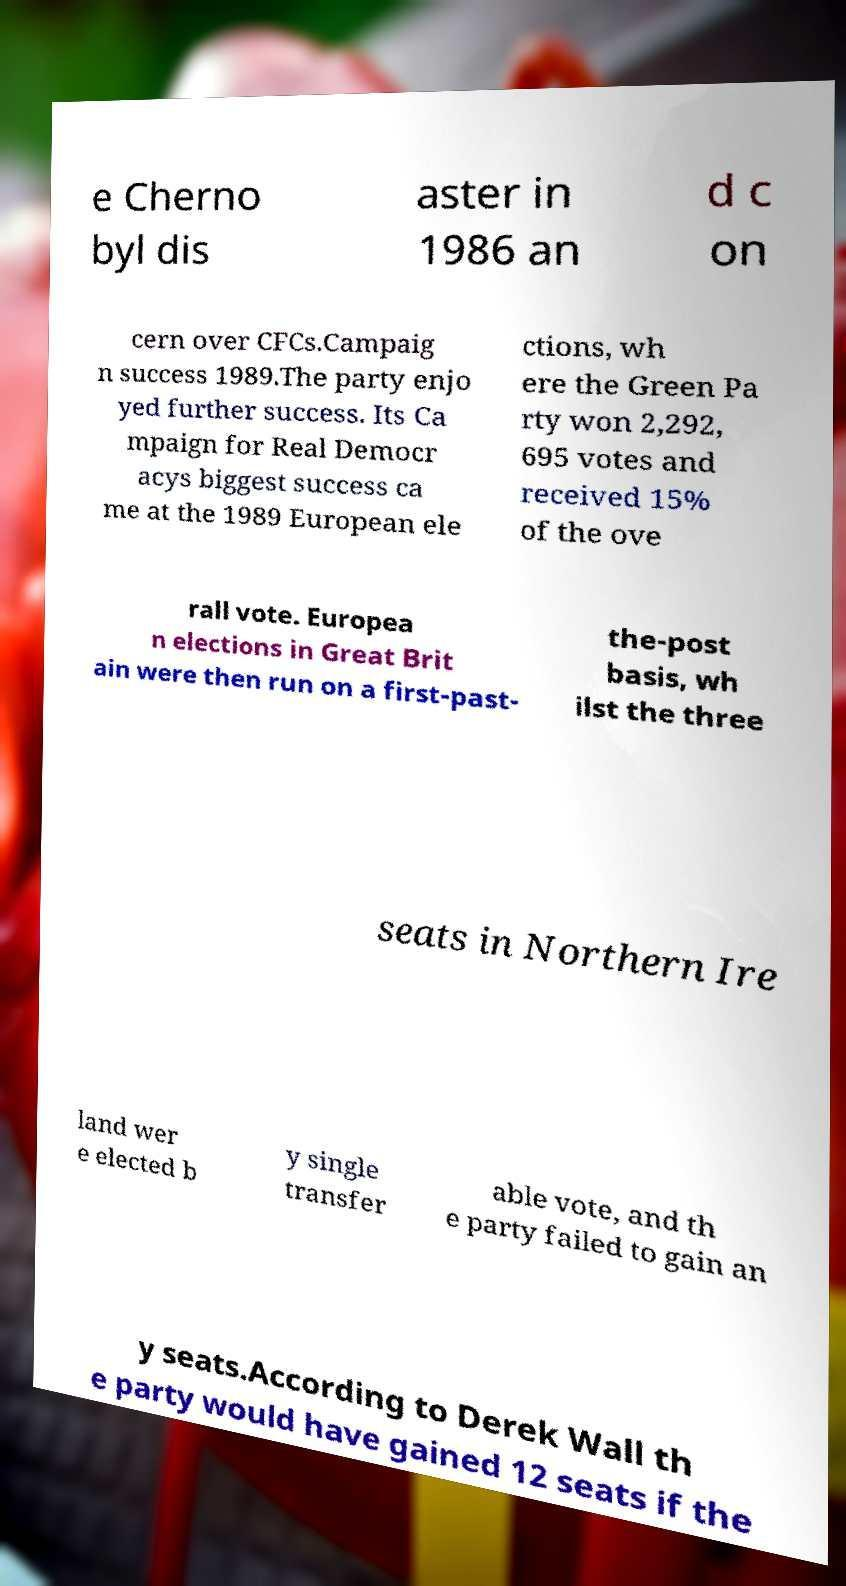There's text embedded in this image that I need extracted. Can you transcribe it verbatim? e Cherno byl dis aster in 1986 an d c on cern over CFCs.Campaig n success 1989.The party enjo yed further success. Its Ca mpaign for Real Democr acys biggest success ca me at the 1989 European ele ctions, wh ere the Green Pa rty won 2,292, 695 votes and received 15% of the ove rall vote. Europea n elections in Great Brit ain were then run on a first-past- the-post basis, wh ilst the three seats in Northern Ire land wer e elected b y single transfer able vote, and th e party failed to gain an y seats.According to Derek Wall th e party would have gained 12 seats if the 